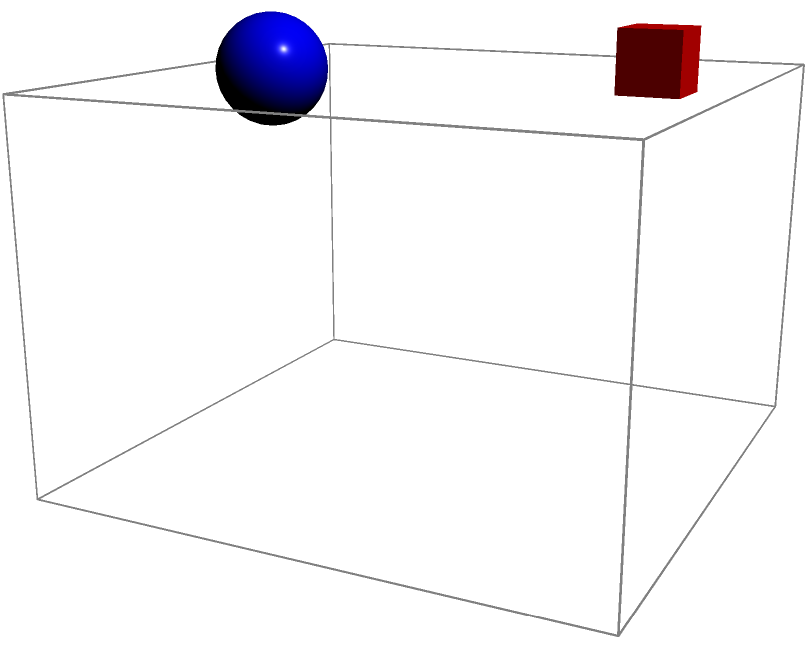A community center with various religious symbols is represented by the 3D model above. If the model is rotated 90° clockwise when viewed from above, which symbol will be closest to the viewer? To solve this problem, we need to follow these steps:

1. Identify the current positions of the symbols:
   - Blue sphere: front-left corner
   - Red cube: back-left corner
   - Green circle: front-right corner
   - Yellow cone: back-right corner

2. Visualize a 90° clockwise rotation when viewed from above:
   - The front-left corner will become the front-right corner
   - The back-left corner will become the front-left corner
   - The front-right corner will become the back-right corner
   - The back-right corner will become the back-left corner

3. Determine the new positions after rotation:
   - Blue sphere: front-right corner
   - Red cube: front-left corner
   - Green circle: back-right corner
   - Yellow cone: back-left corner

4. Identify which symbol is now closest to the viewer:
   The symbols in the front (closer to the viewer) are the blue sphere and the red cube.
   Between these two, the blue sphere is on the right side, which is slightly closer to the viewer in the given perspective.

Therefore, after the 90° clockwise rotation, the blue sphere will be closest to the viewer.
Answer: Blue sphere 